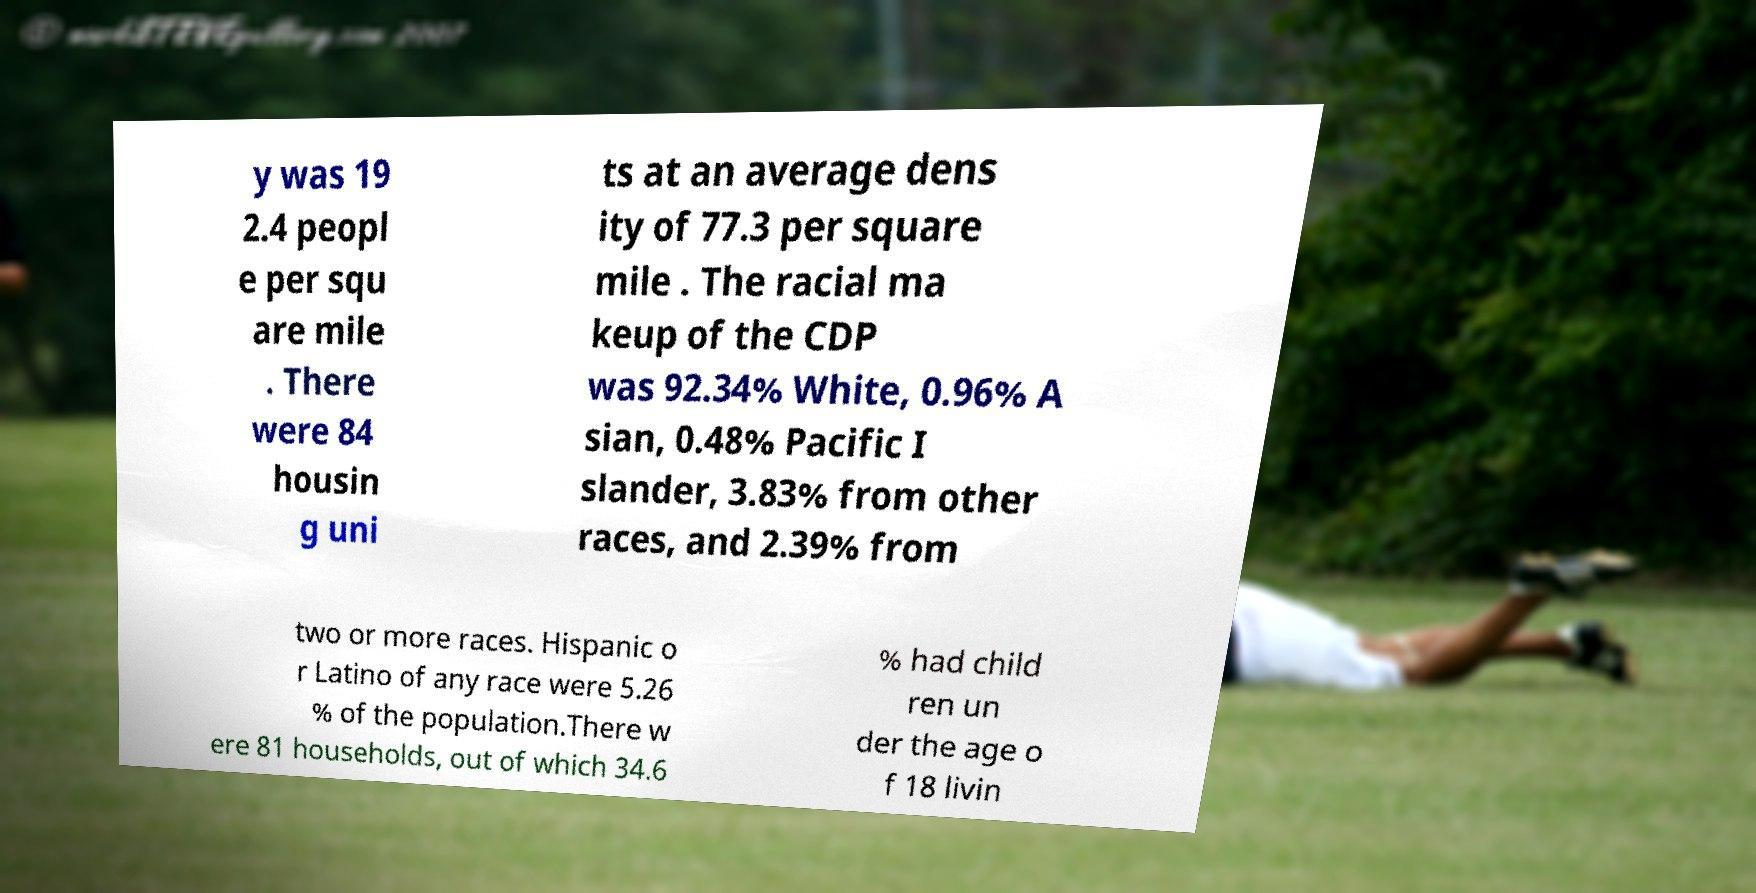Please identify and transcribe the text found in this image. y was 19 2.4 peopl e per squ are mile . There were 84 housin g uni ts at an average dens ity of 77.3 per square mile . The racial ma keup of the CDP was 92.34% White, 0.96% A sian, 0.48% Pacific I slander, 3.83% from other races, and 2.39% from two or more races. Hispanic o r Latino of any race were 5.26 % of the population.There w ere 81 households, out of which 34.6 % had child ren un der the age o f 18 livin 